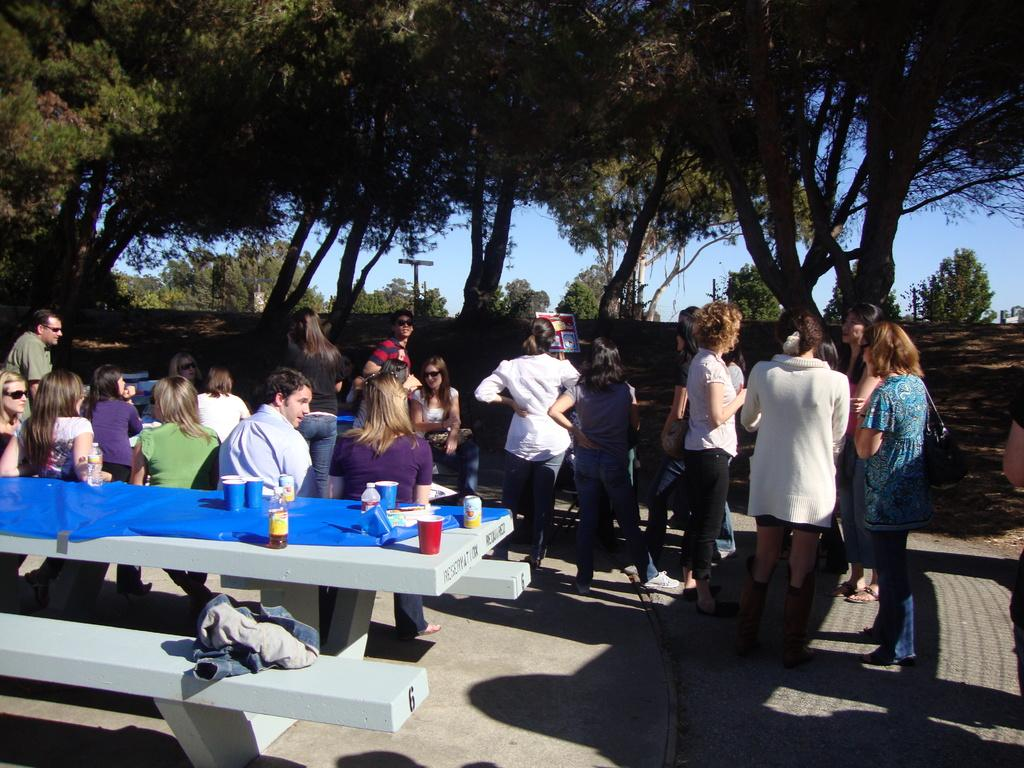How many people are in the image? There is a group of people in the image, but the exact number is not specified. What are the people in the image doing? Some people are standing, while others are sitting. What can be seen on the table in the image? There are cups and bottles on the table. What is visible in the background of the image? There are trees visible in the background. What is visible at the top of the image? The sky is visible at the top of the image. What type of toy is being used by the people in the image? There is no toy present in the image. Where is the camp located in the image? There is no camp present in the image. 